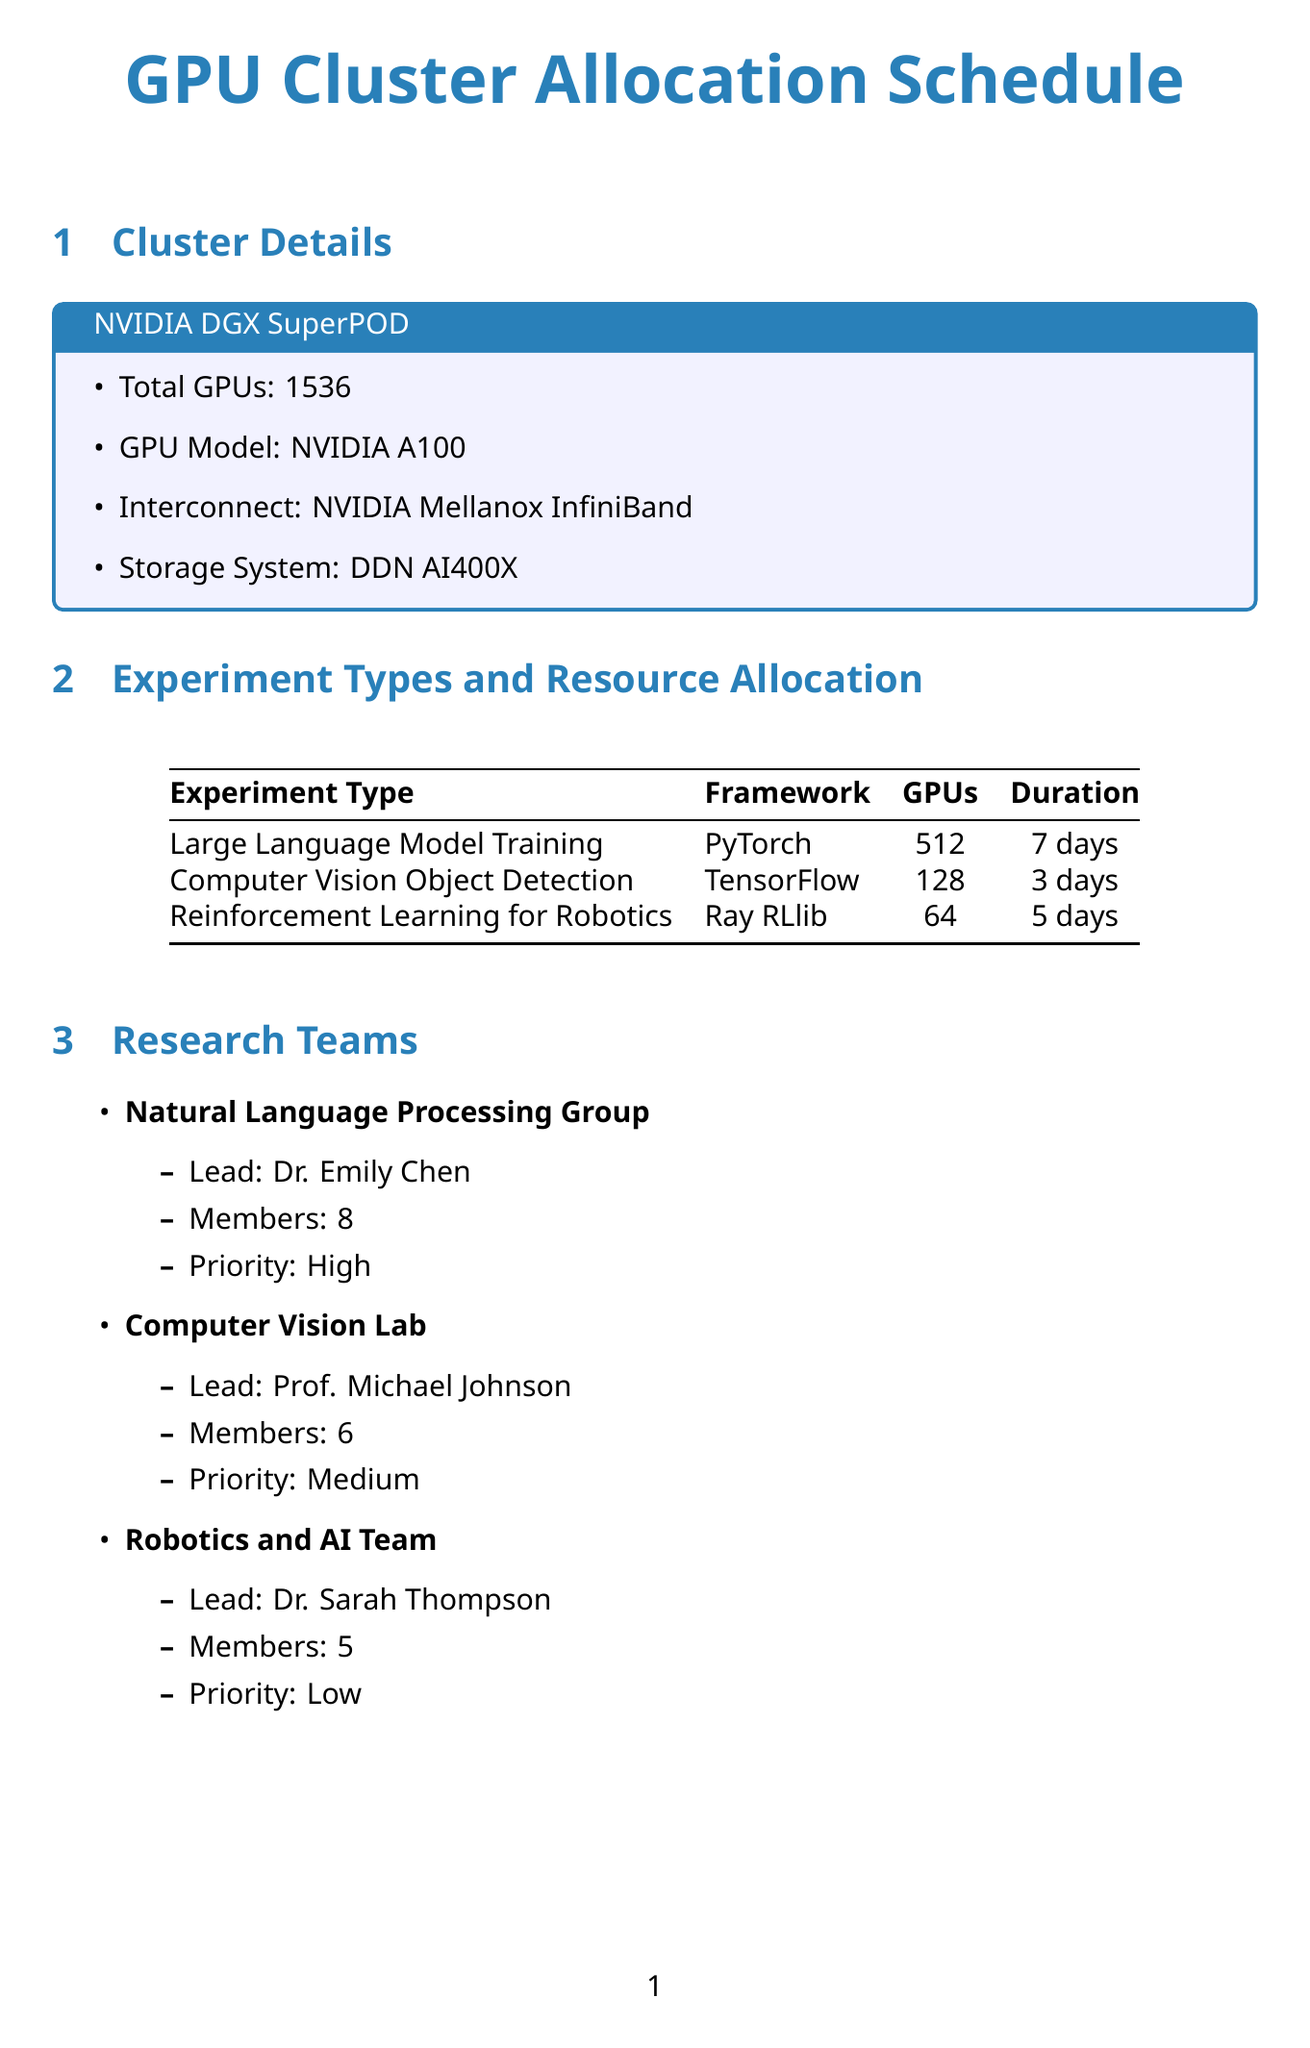What is the name of the GPU cluster? The document provides the name of the GPU cluster in the cluster details section.
Answer: NVIDIA DGX SuperPOD How many total GPUs are available? The total number of GPUs is specified in the cluster details section of the document.
Answer: 1536 Which framework is used for Large Language Model Training? The framework for Large Language Model Training is detailed in the experiment types section.
Answer: PyTorch What is the estimated duration for Computer Vision Object Detection? The estimated duration is mentioned in the experiment types section.
Answer: 3 days Who leads the Computer Vision Lab? The name of the lead for the Computer Vision Lab is indicated in the research teams section.
Answer: Prof. Michael Johnson What scheduling algorithm is suitable for containerized AI workloads? The document explicitly mentions the suitability of scheduling algorithms in the scheduling algorithms section.
Answer: Kubernetes with GPU support What technique provides 10-15% energy savings? The potential impact of the optimization technique is specified in the optimization techniques section.
Answer: Dynamic Voltage and Frequency Scaling (DVFS) What type of resource allocation policy allows advance reservations? The document describes various resource allocation policies, including one that allows for advance reservations.
Answer: Reservation-based allocation Which monitoring tool integrates with Prometheus? The integration information for monitoring tools is included in the monitoring tools section of the document.
Answer: Grafana What priority does the Robotics and AI Team have? The priority level of the Robotics and AI Team is outlined in the research teams section.
Answer: Low 